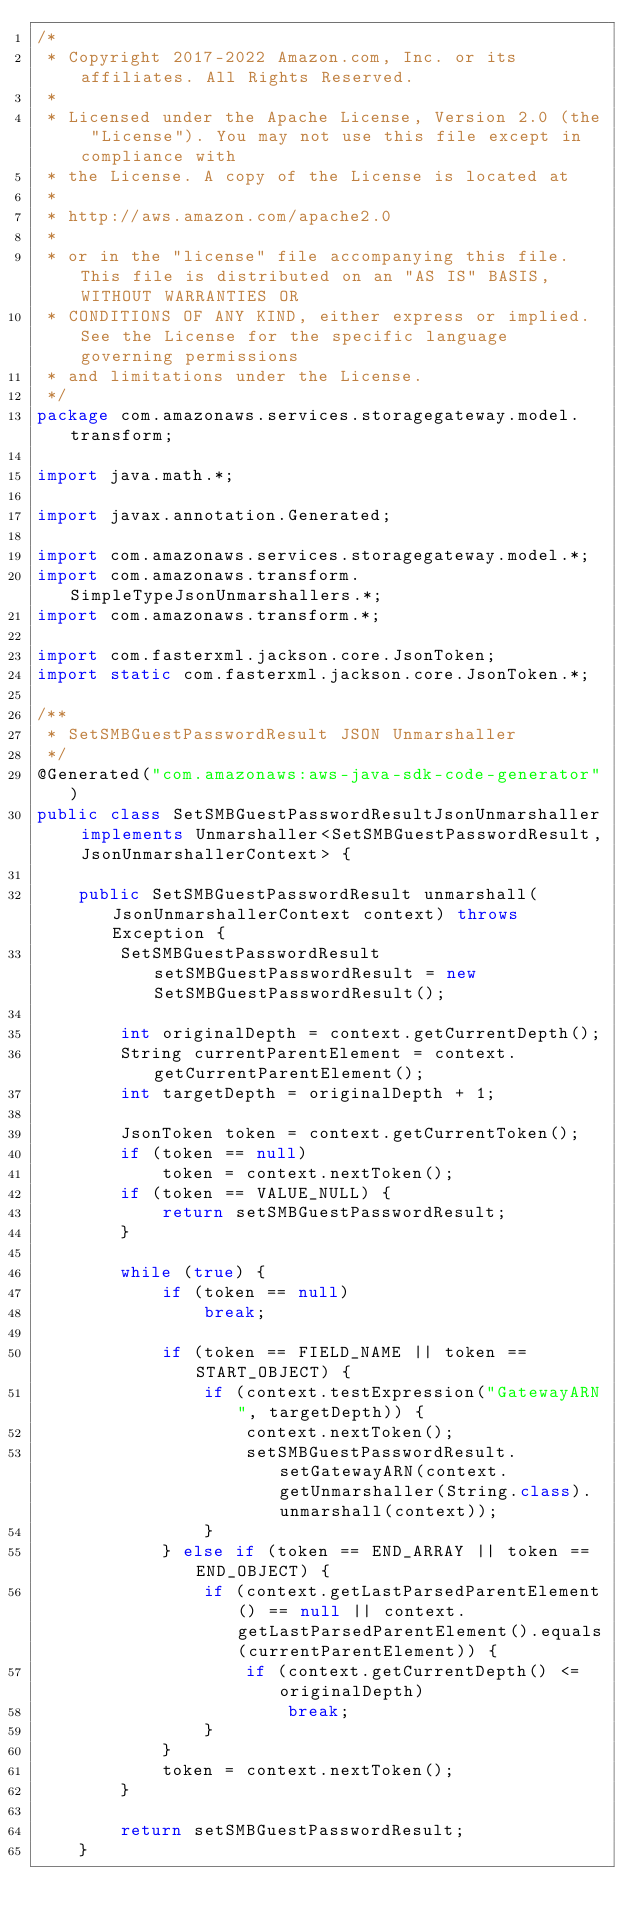Convert code to text. <code><loc_0><loc_0><loc_500><loc_500><_Java_>/*
 * Copyright 2017-2022 Amazon.com, Inc. or its affiliates. All Rights Reserved.
 * 
 * Licensed under the Apache License, Version 2.0 (the "License"). You may not use this file except in compliance with
 * the License. A copy of the License is located at
 * 
 * http://aws.amazon.com/apache2.0
 * 
 * or in the "license" file accompanying this file. This file is distributed on an "AS IS" BASIS, WITHOUT WARRANTIES OR
 * CONDITIONS OF ANY KIND, either express or implied. See the License for the specific language governing permissions
 * and limitations under the License.
 */
package com.amazonaws.services.storagegateway.model.transform;

import java.math.*;

import javax.annotation.Generated;

import com.amazonaws.services.storagegateway.model.*;
import com.amazonaws.transform.SimpleTypeJsonUnmarshallers.*;
import com.amazonaws.transform.*;

import com.fasterxml.jackson.core.JsonToken;
import static com.fasterxml.jackson.core.JsonToken.*;

/**
 * SetSMBGuestPasswordResult JSON Unmarshaller
 */
@Generated("com.amazonaws:aws-java-sdk-code-generator")
public class SetSMBGuestPasswordResultJsonUnmarshaller implements Unmarshaller<SetSMBGuestPasswordResult, JsonUnmarshallerContext> {

    public SetSMBGuestPasswordResult unmarshall(JsonUnmarshallerContext context) throws Exception {
        SetSMBGuestPasswordResult setSMBGuestPasswordResult = new SetSMBGuestPasswordResult();

        int originalDepth = context.getCurrentDepth();
        String currentParentElement = context.getCurrentParentElement();
        int targetDepth = originalDepth + 1;

        JsonToken token = context.getCurrentToken();
        if (token == null)
            token = context.nextToken();
        if (token == VALUE_NULL) {
            return setSMBGuestPasswordResult;
        }

        while (true) {
            if (token == null)
                break;

            if (token == FIELD_NAME || token == START_OBJECT) {
                if (context.testExpression("GatewayARN", targetDepth)) {
                    context.nextToken();
                    setSMBGuestPasswordResult.setGatewayARN(context.getUnmarshaller(String.class).unmarshall(context));
                }
            } else if (token == END_ARRAY || token == END_OBJECT) {
                if (context.getLastParsedParentElement() == null || context.getLastParsedParentElement().equals(currentParentElement)) {
                    if (context.getCurrentDepth() <= originalDepth)
                        break;
                }
            }
            token = context.nextToken();
        }

        return setSMBGuestPasswordResult;
    }
</code> 